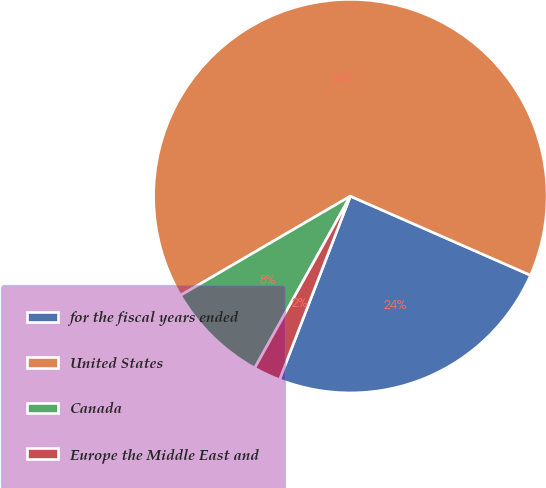<chart> <loc_0><loc_0><loc_500><loc_500><pie_chart><fcel>for the fiscal years ended<fcel>United States<fcel>Canada<fcel>Europe the Middle East and<nl><fcel>24.28%<fcel>65.0%<fcel>8.5%<fcel>2.22%<nl></chart> 